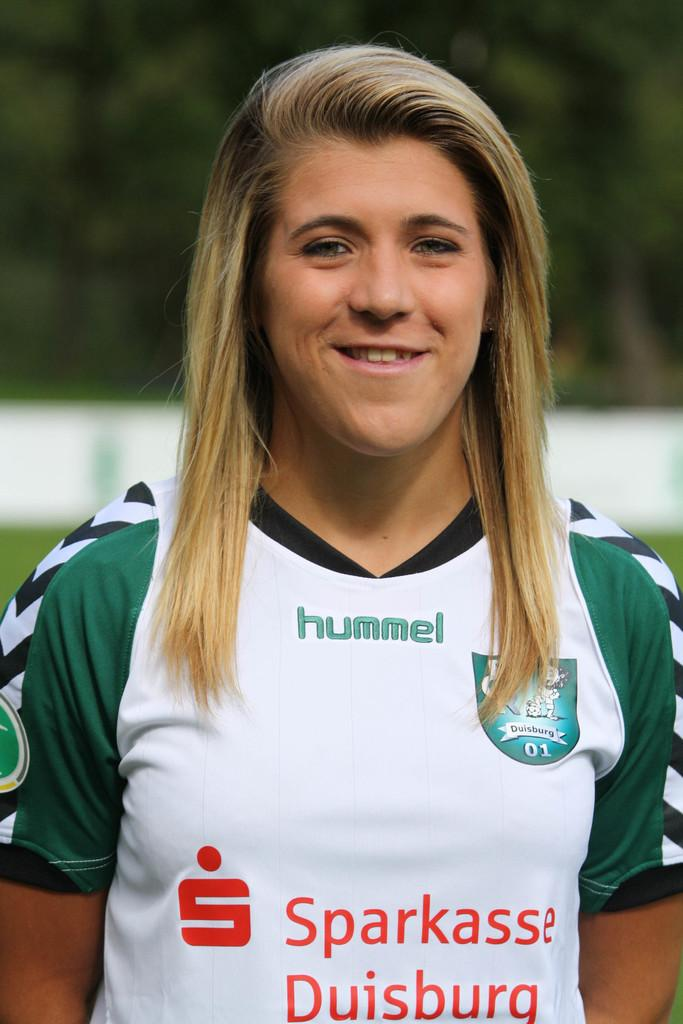<image>
Summarize the visual content of the image. a woman in a HUMMEL Sparkasse Duisburg jersey smiles at the camera 